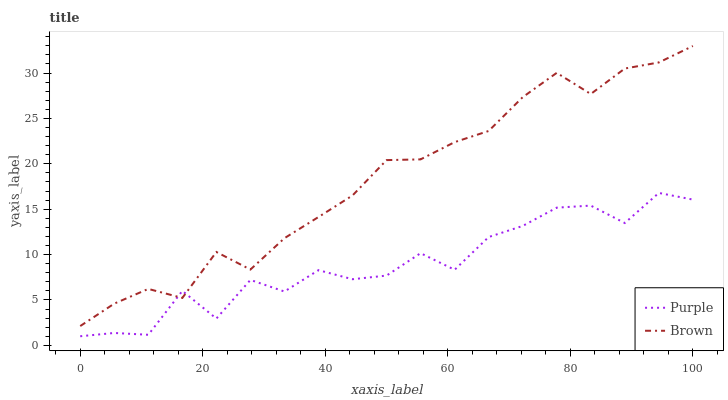Does Purple have the minimum area under the curve?
Answer yes or no. Yes. Does Brown have the maximum area under the curve?
Answer yes or no. Yes. Does Brown have the minimum area under the curve?
Answer yes or no. No. Is Brown the smoothest?
Answer yes or no. Yes. Is Purple the roughest?
Answer yes or no. Yes. Is Brown the roughest?
Answer yes or no. No. Does Purple have the lowest value?
Answer yes or no. Yes. Does Brown have the lowest value?
Answer yes or no. No. Does Brown have the highest value?
Answer yes or no. Yes. Does Purple intersect Brown?
Answer yes or no. Yes. Is Purple less than Brown?
Answer yes or no. No. Is Purple greater than Brown?
Answer yes or no. No. 